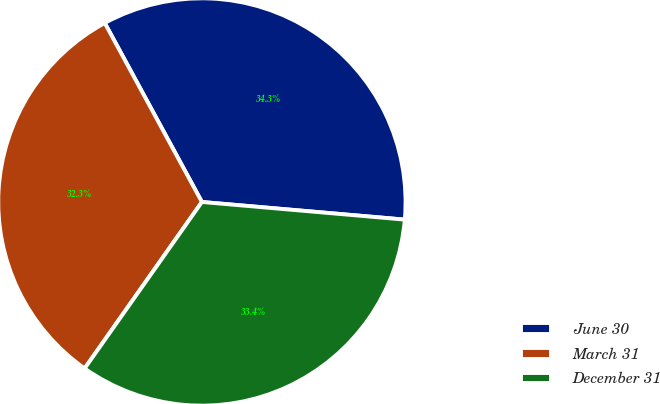Convert chart. <chart><loc_0><loc_0><loc_500><loc_500><pie_chart><fcel>June 30<fcel>March 31<fcel>December 31<nl><fcel>34.3%<fcel>32.32%<fcel>33.39%<nl></chart> 